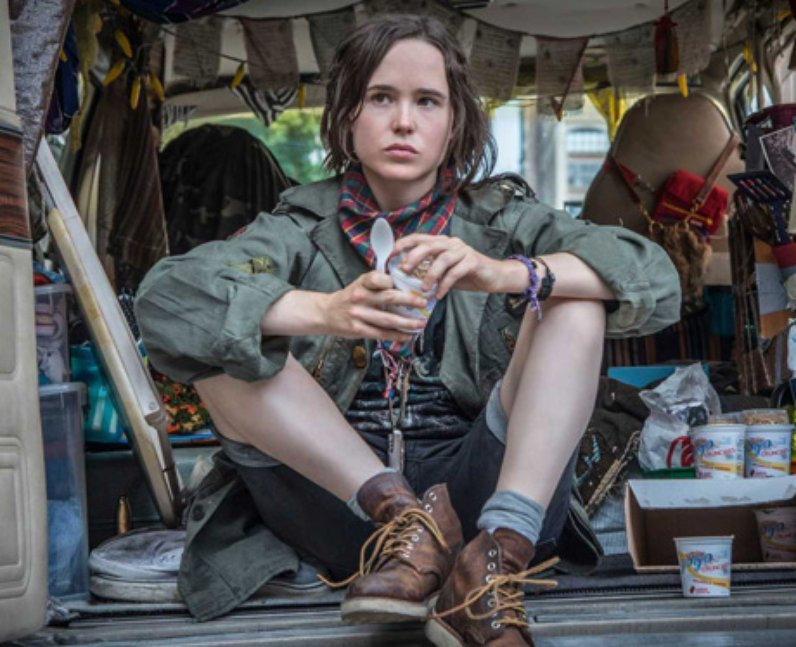What do the various objects hanging from the ceiling and spread on the floor around Elliott suggest about this scene? The array of objects scattered and hung around the van suggests a lived-in, multi-functional space that serves both as a home and a workspace. Items like papers and books might indicate intellectual pursuits or professional preparation, possibly suggesting that Elliot is deeply immersed in a project or role that requires research and close examination. Is there any significance to the rainbow-colored ribbon held by Elliot in this context? The rainbow-colored ribbon held by Elliot can be seen as a powerful symbol of LGBTQ+ pride and diversity, reflecting personal identity and the journey of self-expression. It might also emphasize the character's or Elliot's support and advocacy for inclusivity and equal rights, aligning with themes of personal freedom and identity exploration. 